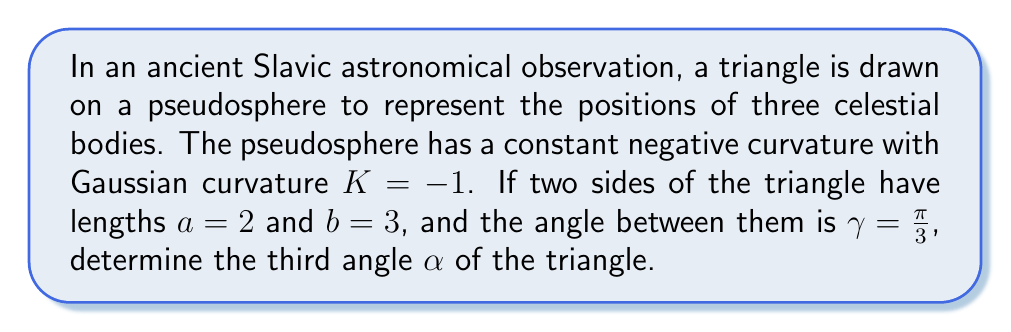Can you answer this question? To solve this problem, we'll use the hyperbolic law of cosines for a pseudosphere, which is a surface of constant negative curvature. The steps are as follows:

1) The hyperbolic law of cosines for a triangle on a pseudosphere with Gaussian curvature $K = -1$ is:

   $$\cosh c = \cosh a \cosh b - \sinh a \sinh b \cos \gamma$$

   where $c$ is the length of the third side.

2) We're given $a = 2$, $b = 3$, and $\gamma = \frac{\pi}{3}$. Let's substitute these values:

   $$\cosh c = \cosh 2 \cosh 3 - \sinh 2 \sinh 3 \cos \frac{\pi}{3}$$

3) Calculate the hyperbolic functions:
   $\cosh 2 \approx 3.7622$
   $\cosh 3 \approx 10.0677$
   $\sinh 2 \approx 3.6269$
   $\sinh 3 \approx 10.0179$
   $\cos \frac{\pi}{3} = 0.5$

4) Substitute these values:

   $$\cosh c = 3.7622 \cdot 10.0677 - 3.6269 \cdot 10.0179 \cdot 0.5 \approx 19.8720$$

5) Now we can find $c$:

   $$c = \text{arccosh}(19.8720) \approx 3.6897$$

6) With all sides known, we can use the hyperbolic law of cosines again to find $\alpha$:

   $$\cosh c = \cosh a \cosh b - \sinh a \sinh b \cos \alpha$$

7) Rearranging to solve for $\cos \alpha$:

   $$\cos \alpha = \frac{\cosh a \cosh b - \cosh c}{\sinh a \sinh b}$$

8) Substitute the values:

   $$\cos \alpha = \frac{3.7622 \cdot 10.0677 - 19.8720}{3.6269 \cdot 10.0179} \approx 0.8909$$

9) Finally, solve for $\alpha$:

   $$\alpha = \arccos(0.8909) \approx 0.4636 \text{ radians}$$
Answer: $\alpha \approx 0.4636 \text{ radians}$ 